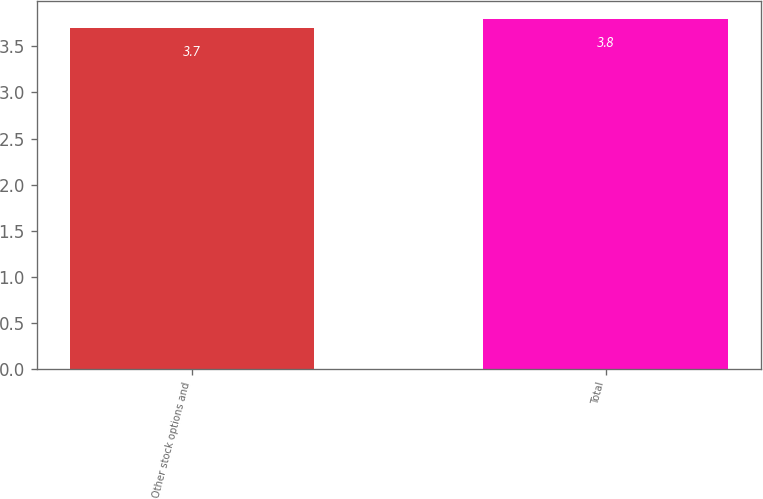<chart> <loc_0><loc_0><loc_500><loc_500><bar_chart><fcel>Other stock options and<fcel>Total<nl><fcel>3.7<fcel>3.8<nl></chart> 